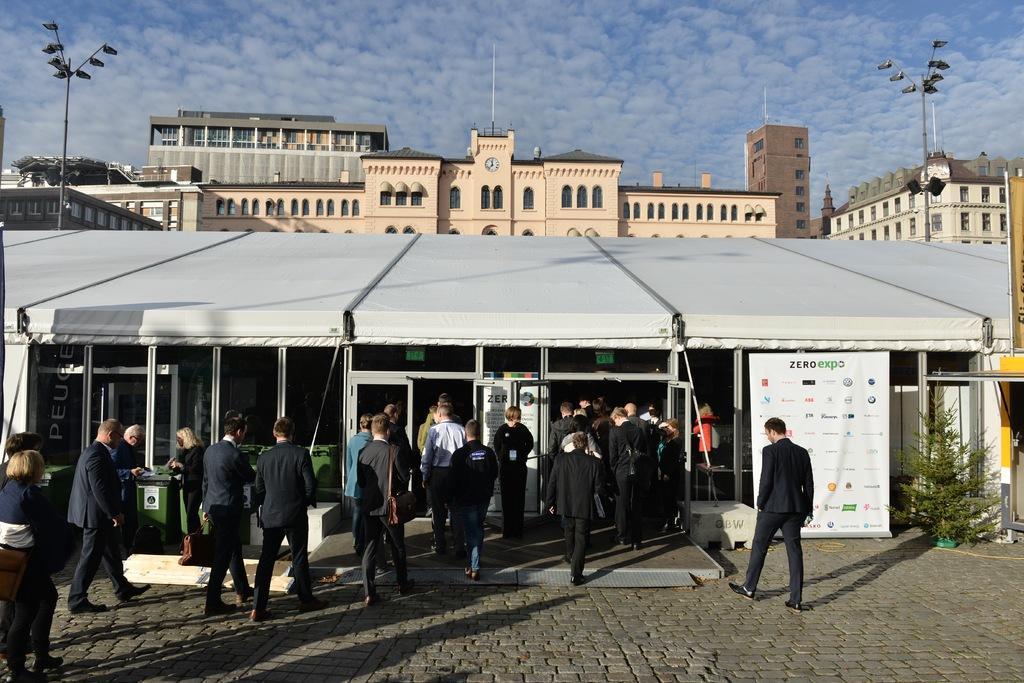In one or two sentences, can you explain what this image depicts? In the picture we can see people, stories,a banner,a plant and dustbins. In the background we can see buildings, street lights, trees and a cloudy sky.  